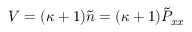Convert formula to latex. <formula><loc_0><loc_0><loc_500><loc_500>V = ( \kappa + 1 ) \tilde { n } = ( \kappa + 1 ) \tilde { P } _ { x x }</formula> 